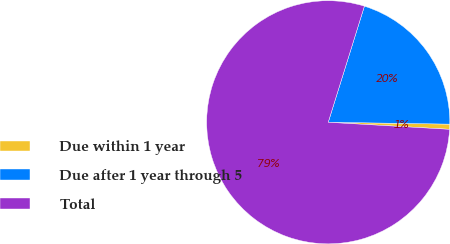Convert chart to OTSL. <chart><loc_0><loc_0><loc_500><loc_500><pie_chart><fcel>Due within 1 year<fcel>Due after 1 year through 5<fcel>Total<nl><fcel>0.68%<fcel>20.44%<fcel>78.89%<nl></chart> 